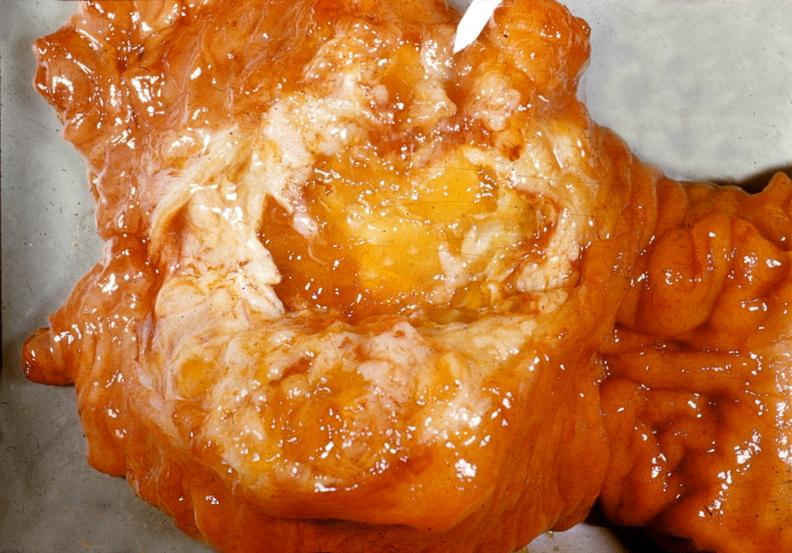what does this image show?
Answer the question using a single word or phrase. Adenocarcinoma 